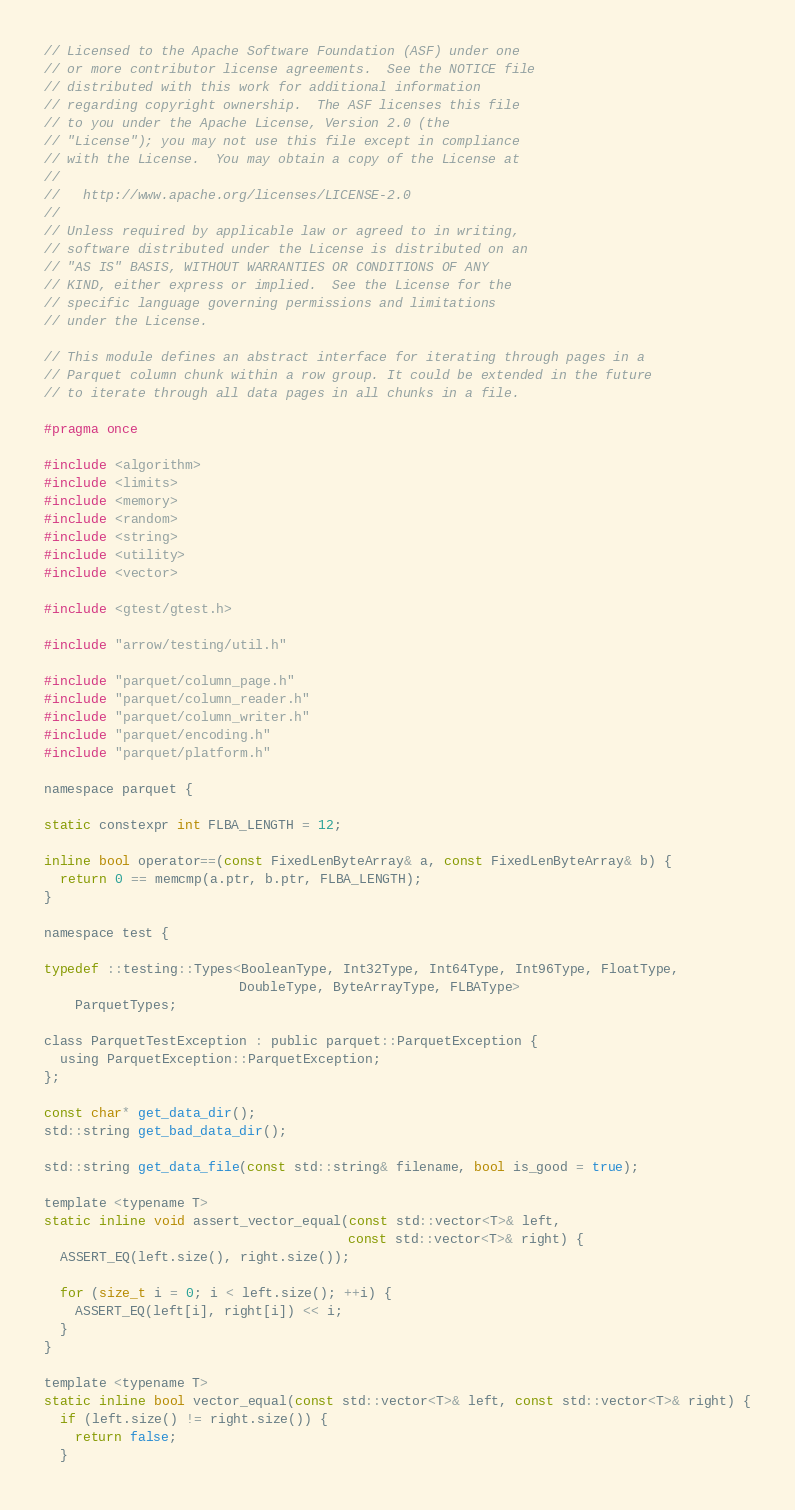Convert code to text. <code><loc_0><loc_0><loc_500><loc_500><_C_>// Licensed to the Apache Software Foundation (ASF) under one
// or more contributor license agreements.  See the NOTICE file
// distributed with this work for additional information
// regarding copyright ownership.  The ASF licenses this file
// to you under the Apache License, Version 2.0 (the
// "License"); you may not use this file except in compliance
// with the License.  You may obtain a copy of the License at
//
//   http://www.apache.org/licenses/LICENSE-2.0
//
// Unless required by applicable law or agreed to in writing,
// software distributed under the License is distributed on an
// "AS IS" BASIS, WITHOUT WARRANTIES OR CONDITIONS OF ANY
// KIND, either express or implied.  See the License for the
// specific language governing permissions and limitations
// under the License.

// This module defines an abstract interface for iterating through pages in a
// Parquet column chunk within a row group. It could be extended in the future
// to iterate through all data pages in all chunks in a file.

#pragma once

#include <algorithm>
#include <limits>
#include <memory>
#include <random>
#include <string>
#include <utility>
#include <vector>

#include <gtest/gtest.h>

#include "arrow/testing/util.h"

#include "parquet/column_page.h"
#include "parquet/column_reader.h"
#include "parquet/column_writer.h"
#include "parquet/encoding.h"
#include "parquet/platform.h"

namespace parquet {

static constexpr int FLBA_LENGTH = 12;

inline bool operator==(const FixedLenByteArray& a, const FixedLenByteArray& b) {
  return 0 == memcmp(a.ptr, b.ptr, FLBA_LENGTH);
}

namespace test {

typedef ::testing::Types<BooleanType, Int32Type, Int64Type, Int96Type, FloatType,
                         DoubleType, ByteArrayType, FLBAType>
    ParquetTypes;

class ParquetTestException : public parquet::ParquetException {
  using ParquetException::ParquetException;
};

const char* get_data_dir();
std::string get_bad_data_dir();

std::string get_data_file(const std::string& filename, bool is_good = true);

template <typename T>
static inline void assert_vector_equal(const std::vector<T>& left,
                                       const std::vector<T>& right) {
  ASSERT_EQ(left.size(), right.size());

  for (size_t i = 0; i < left.size(); ++i) {
    ASSERT_EQ(left[i], right[i]) << i;
  }
}

template <typename T>
static inline bool vector_equal(const std::vector<T>& left, const std::vector<T>& right) {
  if (left.size() != right.size()) {
    return false;
  }
</code> 